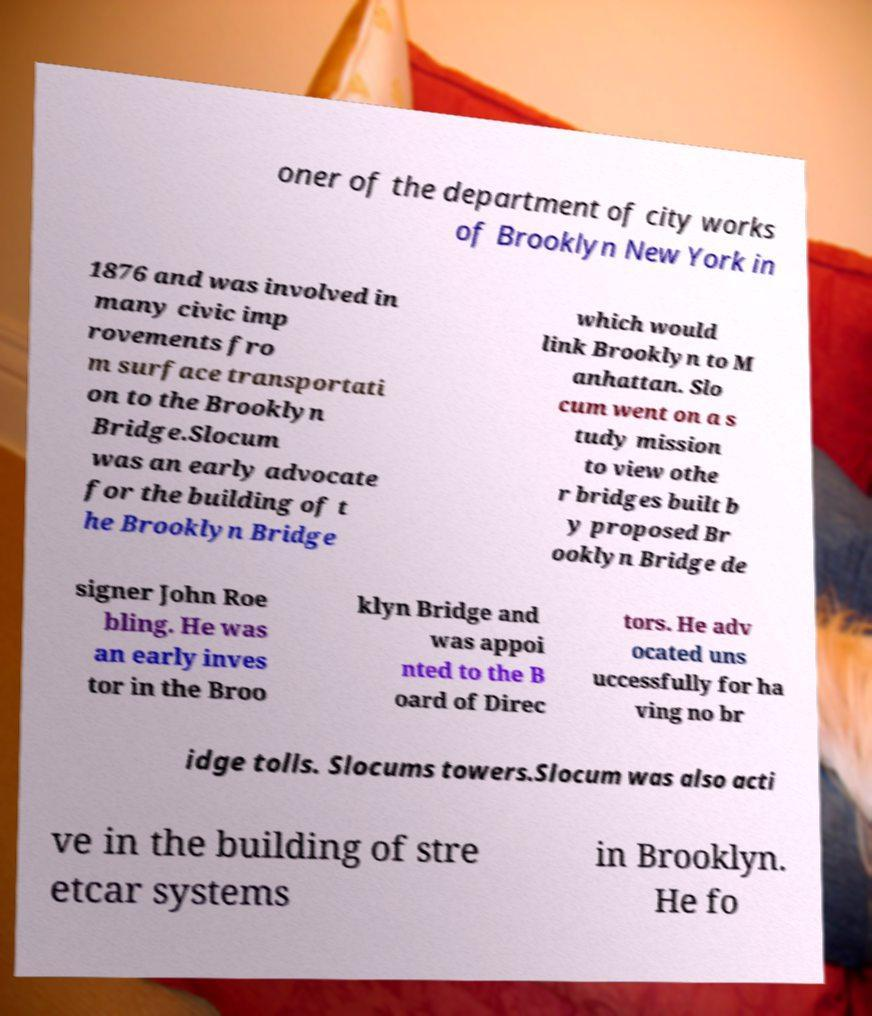What messages or text are displayed in this image? I need them in a readable, typed format. oner of the department of city works of Brooklyn New York in 1876 and was involved in many civic imp rovements fro m surface transportati on to the Brooklyn Bridge.Slocum was an early advocate for the building of t he Brooklyn Bridge which would link Brooklyn to M anhattan. Slo cum went on a s tudy mission to view othe r bridges built b y proposed Br ooklyn Bridge de signer John Roe bling. He was an early inves tor in the Broo klyn Bridge and was appoi nted to the B oard of Direc tors. He adv ocated uns uccessfully for ha ving no br idge tolls. Slocums towers.Slocum was also acti ve in the building of stre etcar systems in Brooklyn. He fo 